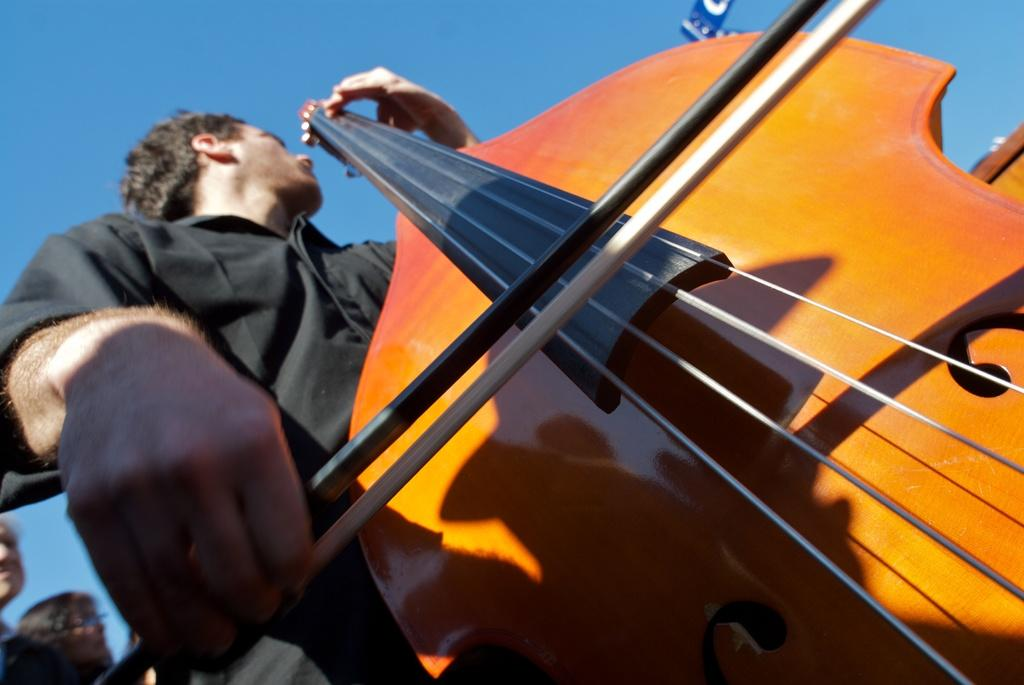Where was the image taken? The image was clicked outside. What is the man in the image doing? The man is playing the violin. What color is the shirt the man is wearing? The man is wearing a black color shirt. Are there any other people in the image? Yes, there are people behind the man. What is the color of the sky in the image? The sky is blue. Can you see any snails crawling on the violin in the image? No, there are no snails visible in the image. How does the chicken in the image look at the man playing the violin? There is no chicken present in the image. 